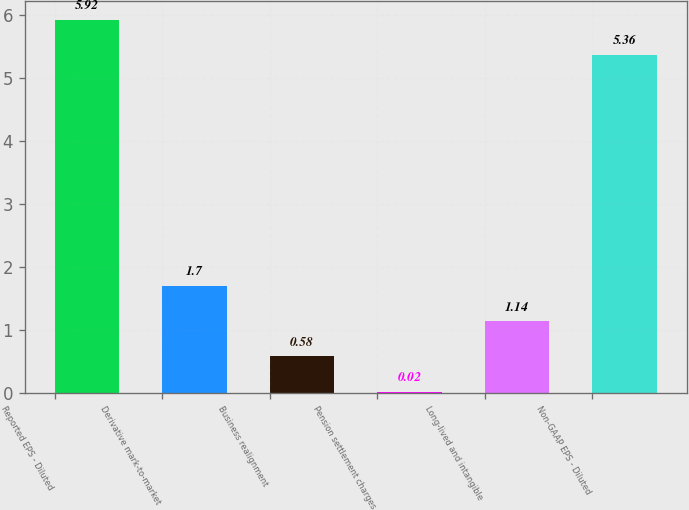Convert chart to OTSL. <chart><loc_0><loc_0><loc_500><loc_500><bar_chart><fcel>Reported EPS - Diluted<fcel>Derivative mark-to-market<fcel>Business realignment<fcel>Pension settlement charges<fcel>Long-lived and intangible<fcel>Non-GAAP EPS - Diluted<nl><fcel>5.92<fcel>1.7<fcel>0.58<fcel>0.02<fcel>1.14<fcel>5.36<nl></chart> 